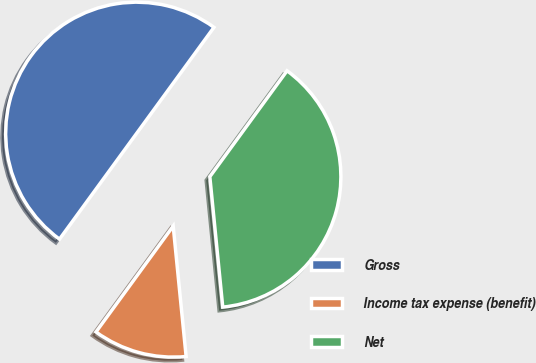Convert chart to OTSL. <chart><loc_0><loc_0><loc_500><loc_500><pie_chart><fcel>Gross<fcel>Income tax expense (benefit)<fcel>Net<nl><fcel>50.0%<fcel>11.6%<fcel>38.4%<nl></chart> 